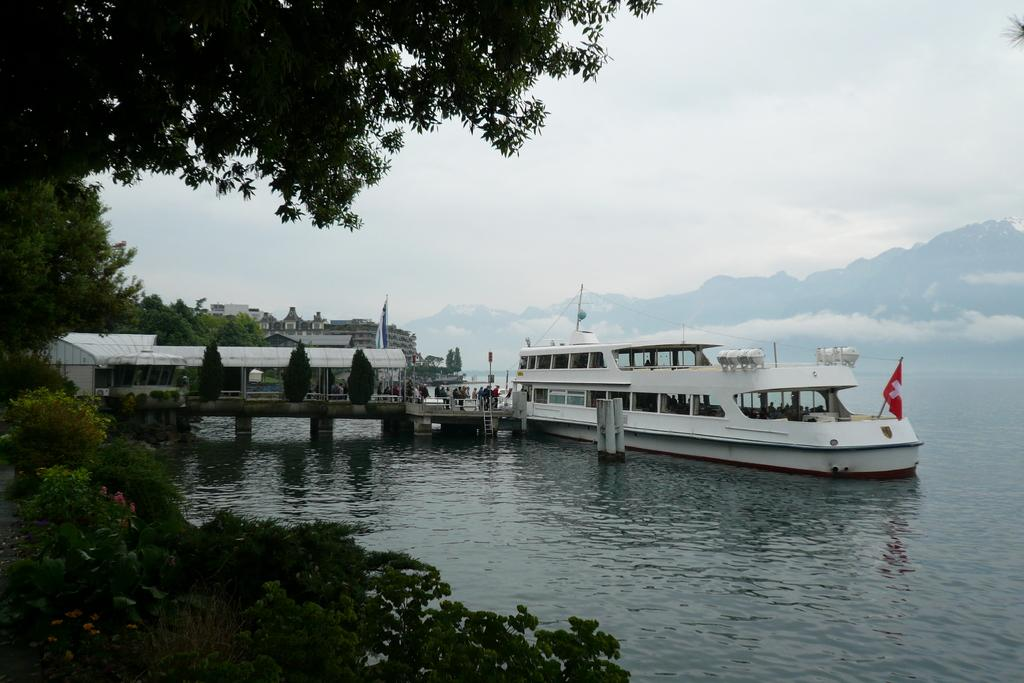What is the main feature of the image? The main feature of the image is water. What is on the water in the image? There is a boat with a flag on the water. What can be seen on the left side of the image? There are trees, buildings, and a bridge on the left side of the image. Are there any people in the image? Yes, there are people in the image. How many roses can be seen in the image? There are no roses present in the image. What achievement has the person in the image accomplished? The image does not provide information about any achievements or accomplishments of the people in the image. 